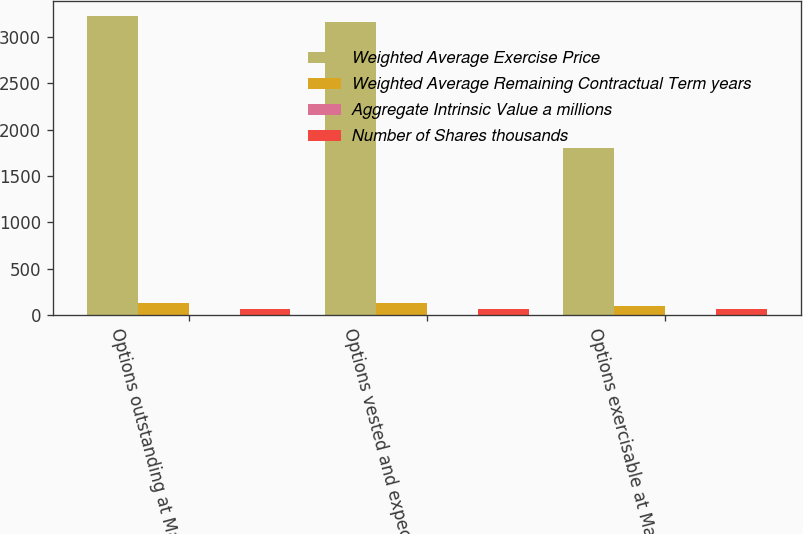Convert chart to OTSL. <chart><loc_0><loc_0><loc_500><loc_500><stacked_bar_chart><ecel><fcel>Options outstanding at March<fcel>Options vested and expected to<fcel>Options exercisable at March<nl><fcel>Weighted Average Exercise Price<fcel>3225<fcel>3159<fcel>1802<nl><fcel>Weighted Average Remaining Contractual Term years<fcel>129.28<fcel>128.57<fcel>101.89<nl><fcel>Aggregate Intrinsic Value a millions<fcel>4<fcel>4<fcel>2.6<nl><fcel>Number of Shares thousands<fcel>69<fcel>69<fcel>69<nl></chart> 